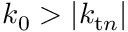Convert formula to latex. <formula><loc_0><loc_0><loc_500><loc_500>k _ { 0 } > | k _ { t n } |</formula> 